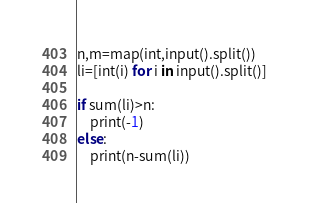Convert code to text. <code><loc_0><loc_0><loc_500><loc_500><_Python_>n,m=map(int,input().split())
li=[int(i) for i in input().split()]

if sum(li)>n:
    print(-1)
else:
    print(n-sum(li))</code> 